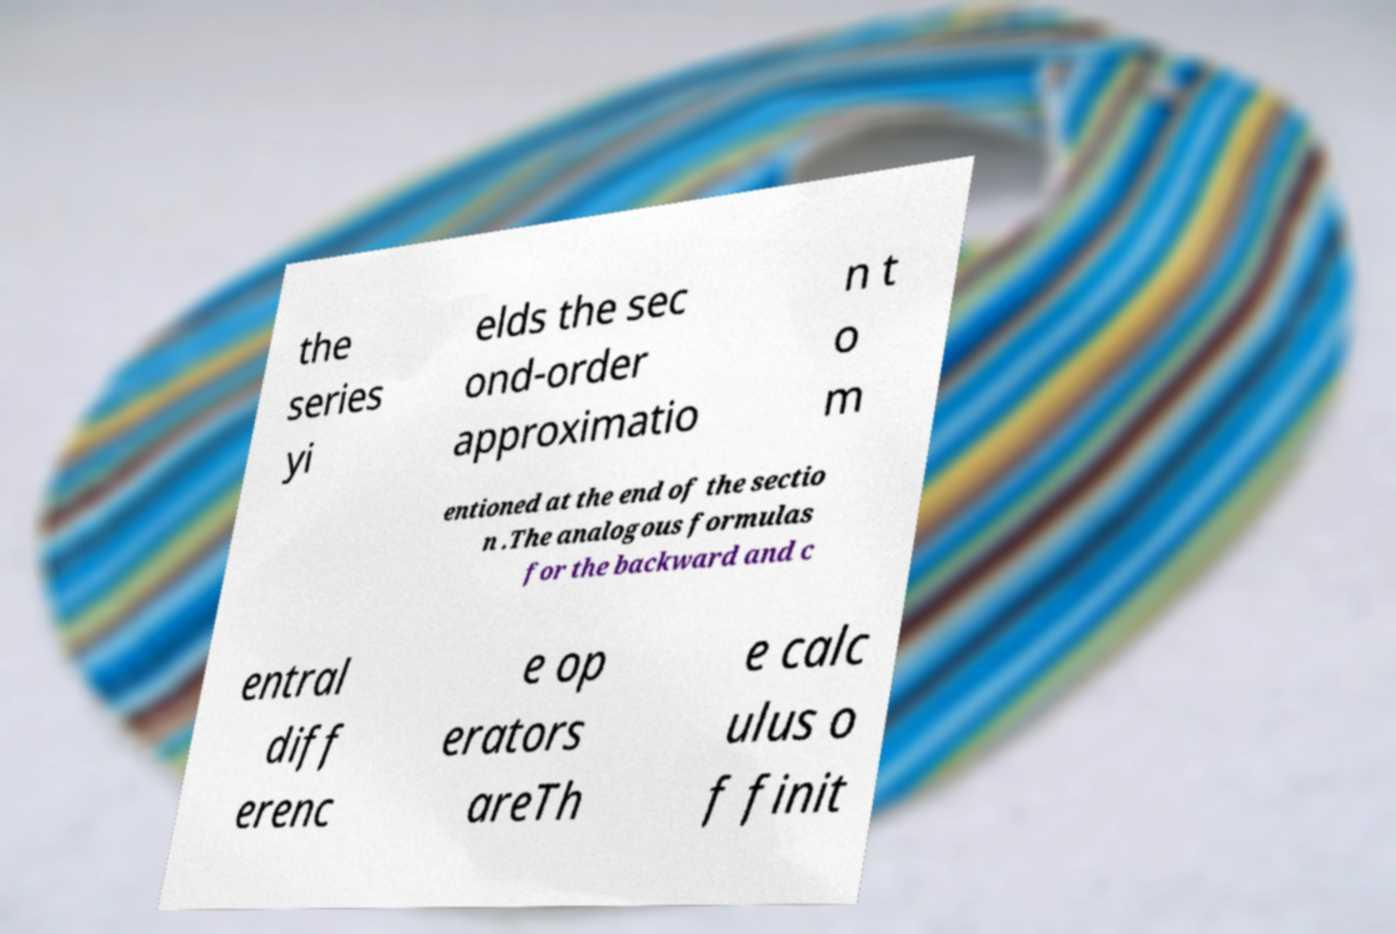Could you assist in decoding the text presented in this image and type it out clearly? the series yi elds the sec ond-order approximatio n t o m entioned at the end of the sectio n .The analogous formulas for the backward and c entral diff erenc e op erators areTh e calc ulus o f finit 